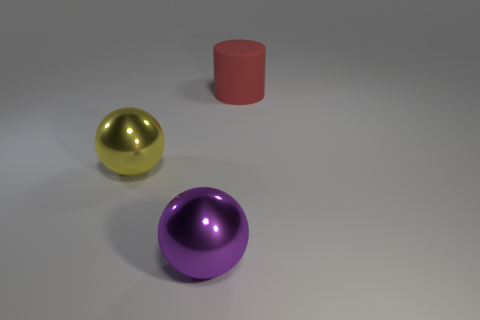Is there anything else that has the same material as the large red object?
Your response must be concise. No. What number of cylinders are either big things or purple metal objects?
Provide a short and direct response. 1. Is the number of rubber objects in front of the purple object less than the number of big red objects that are on the left side of the large red matte cylinder?
Offer a terse response. No. How many objects are large objects that are to the left of the large rubber cylinder or big shiny objects?
Offer a very short reply. 2. What shape is the large thing that is behind the sphere behind the large purple metal ball?
Ensure brevity in your answer.  Cylinder. Are there any purple metal spheres of the same size as the red cylinder?
Offer a very short reply. Yes. Are there more shiny things than large cyan rubber cubes?
Give a very brief answer. Yes. Is the size of the ball left of the purple metallic object the same as the shiny object in front of the yellow thing?
Keep it short and to the point. Yes. What number of things are both behind the purple metal thing and left of the big rubber object?
Provide a short and direct response. 1. What color is the other large thing that is the same shape as the purple metallic object?
Give a very brief answer. Yellow. 